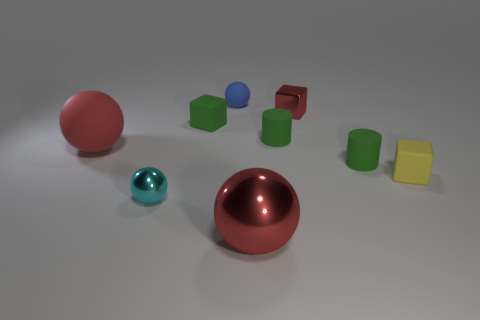Does the big metallic thing have the same color as the tiny metal object that is behind the big red matte ball?
Offer a very short reply. Yes. There is a ball that is both on the right side of the cyan object and behind the tiny yellow cube; what color is it?
Your response must be concise. Blue. There is a rubber sphere that is left of the blue matte object; how many tiny rubber things are behind it?
Give a very brief answer. 3. Are there any tiny yellow rubber things of the same shape as the big red matte object?
Your response must be concise. No. Is the shape of the large thing that is behind the small yellow cube the same as the large thing that is in front of the red rubber thing?
Provide a short and direct response. Yes. What number of things are small cyan things or tiny yellow shiny cubes?
Your response must be concise. 1. What size is the other red thing that is the same shape as the big red matte thing?
Offer a terse response. Large. Is the number of tiny green rubber things on the left side of the red rubber thing greater than the number of green objects?
Your answer should be very brief. No. Does the small red thing have the same material as the blue sphere?
Keep it short and to the point. No. How many things are rubber things that are in front of the red cube or tiny green things that are on the left side of the tiny blue thing?
Offer a very short reply. 5. 